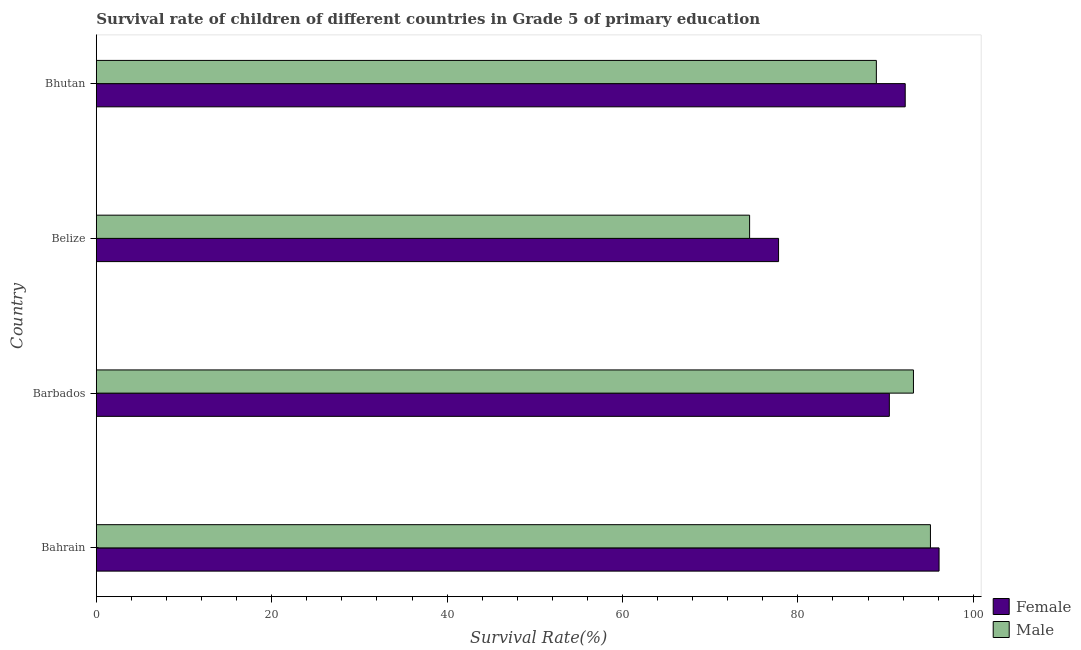Are the number of bars per tick equal to the number of legend labels?
Ensure brevity in your answer.  Yes. How many bars are there on the 1st tick from the bottom?
Your answer should be very brief. 2. What is the label of the 3rd group of bars from the top?
Your answer should be compact. Barbados. In how many cases, is the number of bars for a given country not equal to the number of legend labels?
Offer a very short reply. 0. What is the survival rate of male students in primary education in Bahrain?
Offer a very short reply. 95.11. Across all countries, what is the maximum survival rate of male students in primary education?
Make the answer very short. 95.11. Across all countries, what is the minimum survival rate of male students in primary education?
Make the answer very short. 74.49. In which country was the survival rate of female students in primary education maximum?
Provide a succinct answer. Bahrain. In which country was the survival rate of female students in primary education minimum?
Offer a terse response. Belize. What is the total survival rate of male students in primary education in the graph?
Ensure brevity in your answer.  351.73. What is the difference between the survival rate of female students in primary education in Belize and that in Bhutan?
Offer a terse response. -14.44. What is the difference between the survival rate of female students in primary education in Bhutan and the survival rate of male students in primary education in Belize?
Provide a succinct answer. 17.74. What is the average survival rate of male students in primary education per country?
Your answer should be compact. 87.93. What is the difference between the survival rate of male students in primary education and survival rate of female students in primary education in Belize?
Offer a very short reply. -3.3. What is the ratio of the survival rate of male students in primary education in Bahrain to that in Bhutan?
Give a very brief answer. 1.07. What is the difference between the highest and the second highest survival rate of female students in primary education?
Offer a very short reply. 3.86. What is the difference between the highest and the lowest survival rate of male students in primary education?
Offer a terse response. 20.62. Is the sum of the survival rate of female students in primary education in Belize and Bhutan greater than the maximum survival rate of male students in primary education across all countries?
Ensure brevity in your answer.  Yes. What does the 2nd bar from the bottom in Belize represents?
Offer a very short reply. Male. How many countries are there in the graph?
Provide a succinct answer. 4. What is the difference between two consecutive major ticks on the X-axis?
Offer a very short reply. 20. Are the values on the major ticks of X-axis written in scientific E-notation?
Your response must be concise. No. Where does the legend appear in the graph?
Ensure brevity in your answer.  Bottom right. How many legend labels are there?
Ensure brevity in your answer.  2. What is the title of the graph?
Your answer should be very brief. Survival rate of children of different countries in Grade 5 of primary education. What is the label or title of the X-axis?
Ensure brevity in your answer.  Survival Rate(%). What is the label or title of the Y-axis?
Your response must be concise. Country. What is the Survival Rate(%) of Female in Bahrain?
Offer a very short reply. 96.1. What is the Survival Rate(%) of Male in Bahrain?
Your response must be concise. 95.11. What is the Survival Rate(%) in Female in Barbados?
Offer a very short reply. 90.43. What is the Survival Rate(%) of Male in Barbados?
Offer a terse response. 93.18. What is the Survival Rate(%) of Female in Belize?
Ensure brevity in your answer.  77.79. What is the Survival Rate(%) of Male in Belize?
Your answer should be very brief. 74.49. What is the Survival Rate(%) in Female in Bhutan?
Give a very brief answer. 92.24. What is the Survival Rate(%) in Male in Bhutan?
Give a very brief answer. 88.95. Across all countries, what is the maximum Survival Rate(%) in Female?
Ensure brevity in your answer.  96.1. Across all countries, what is the maximum Survival Rate(%) in Male?
Make the answer very short. 95.11. Across all countries, what is the minimum Survival Rate(%) in Female?
Your answer should be very brief. 77.79. Across all countries, what is the minimum Survival Rate(%) of Male?
Provide a succinct answer. 74.49. What is the total Survival Rate(%) of Female in the graph?
Offer a very short reply. 356.56. What is the total Survival Rate(%) in Male in the graph?
Provide a short and direct response. 351.73. What is the difference between the Survival Rate(%) in Female in Bahrain and that in Barbados?
Your response must be concise. 5.67. What is the difference between the Survival Rate(%) in Male in Bahrain and that in Barbados?
Provide a short and direct response. 1.94. What is the difference between the Survival Rate(%) of Female in Bahrain and that in Belize?
Your answer should be very brief. 18.3. What is the difference between the Survival Rate(%) of Male in Bahrain and that in Belize?
Offer a terse response. 20.62. What is the difference between the Survival Rate(%) in Female in Bahrain and that in Bhutan?
Keep it short and to the point. 3.86. What is the difference between the Survival Rate(%) of Male in Bahrain and that in Bhutan?
Offer a terse response. 6.17. What is the difference between the Survival Rate(%) of Female in Barbados and that in Belize?
Provide a short and direct response. 12.63. What is the difference between the Survival Rate(%) of Male in Barbados and that in Belize?
Give a very brief answer. 18.68. What is the difference between the Survival Rate(%) of Female in Barbados and that in Bhutan?
Keep it short and to the point. -1.81. What is the difference between the Survival Rate(%) of Male in Barbados and that in Bhutan?
Keep it short and to the point. 4.23. What is the difference between the Survival Rate(%) in Female in Belize and that in Bhutan?
Provide a short and direct response. -14.44. What is the difference between the Survival Rate(%) of Male in Belize and that in Bhutan?
Your response must be concise. -14.45. What is the difference between the Survival Rate(%) of Female in Bahrain and the Survival Rate(%) of Male in Barbados?
Your response must be concise. 2.92. What is the difference between the Survival Rate(%) of Female in Bahrain and the Survival Rate(%) of Male in Belize?
Keep it short and to the point. 21.6. What is the difference between the Survival Rate(%) of Female in Bahrain and the Survival Rate(%) of Male in Bhutan?
Make the answer very short. 7.15. What is the difference between the Survival Rate(%) in Female in Barbados and the Survival Rate(%) in Male in Belize?
Provide a succinct answer. 15.93. What is the difference between the Survival Rate(%) of Female in Barbados and the Survival Rate(%) of Male in Bhutan?
Your answer should be very brief. 1.48. What is the difference between the Survival Rate(%) in Female in Belize and the Survival Rate(%) in Male in Bhutan?
Offer a very short reply. -11.15. What is the average Survival Rate(%) of Female per country?
Offer a very short reply. 89.14. What is the average Survival Rate(%) of Male per country?
Your answer should be very brief. 87.93. What is the difference between the Survival Rate(%) in Female and Survival Rate(%) in Male in Bahrain?
Make the answer very short. 0.98. What is the difference between the Survival Rate(%) in Female and Survival Rate(%) in Male in Barbados?
Make the answer very short. -2.75. What is the difference between the Survival Rate(%) of Female and Survival Rate(%) of Male in Belize?
Your answer should be compact. 3.3. What is the difference between the Survival Rate(%) of Female and Survival Rate(%) of Male in Bhutan?
Provide a short and direct response. 3.29. What is the ratio of the Survival Rate(%) in Female in Bahrain to that in Barbados?
Offer a very short reply. 1.06. What is the ratio of the Survival Rate(%) in Male in Bahrain to that in Barbados?
Make the answer very short. 1.02. What is the ratio of the Survival Rate(%) of Female in Bahrain to that in Belize?
Your answer should be very brief. 1.24. What is the ratio of the Survival Rate(%) of Male in Bahrain to that in Belize?
Your answer should be compact. 1.28. What is the ratio of the Survival Rate(%) of Female in Bahrain to that in Bhutan?
Your answer should be very brief. 1.04. What is the ratio of the Survival Rate(%) of Male in Bahrain to that in Bhutan?
Your response must be concise. 1.07. What is the ratio of the Survival Rate(%) in Female in Barbados to that in Belize?
Your answer should be very brief. 1.16. What is the ratio of the Survival Rate(%) in Male in Barbados to that in Belize?
Your answer should be very brief. 1.25. What is the ratio of the Survival Rate(%) of Female in Barbados to that in Bhutan?
Ensure brevity in your answer.  0.98. What is the ratio of the Survival Rate(%) in Male in Barbados to that in Bhutan?
Make the answer very short. 1.05. What is the ratio of the Survival Rate(%) in Female in Belize to that in Bhutan?
Your answer should be compact. 0.84. What is the ratio of the Survival Rate(%) of Male in Belize to that in Bhutan?
Offer a terse response. 0.84. What is the difference between the highest and the second highest Survival Rate(%) of Female?
Give a very brief answer. 3.86. What is the difference between the highest and the second highest Survival Rate(%) in Male?
Offer a terse response. 1.94. What is the difference between the highest and the lowest Survival Rate(%) of Female?
Give a very brief answer. 18.3. What is the difference between the highest and the lowest Survival Rate(%) of Male?
Offer a very short reply. 20.62. 